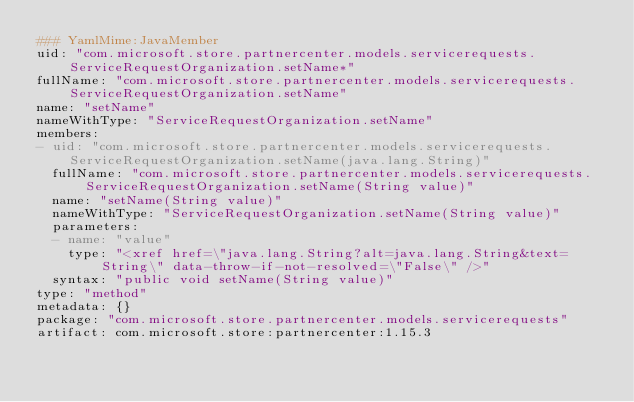<code> <loc_0><loc_0><loc_500><loc_500><_YAML_>### YamlMime:JavaMember
uid: "com.microsoft.store.partnercenter.models.servicerequests.ServiceRequestOrganization.setName*"
fullName: "com.microsoft.store.partnercenter.models.servicerequests.ServiceRequestOrganization.setName"
name: "setName"
nameWithType: "ServiceRequestOrganization.setName"
members:
- uid: "com.microsoft.store.partnercenter.models.servicerequests.ServiceRequestOrganization.setName(java.lang.String)"
  fullName: "com.microsoft.store.partnercenter.models.servicerequests.ServiceRequestOrganization.setName(String value)"
  name: "setName(String value)"
  nameWithType: "ServiceRequestOrganization.setName(String value)"
  parameters:
  - name: "value"
    type: "<xref href=\"java.lang.String?alt=java.lang.String&text=String\" data-throw-if-not-resolved=\"False\" />"
  syntax: "public void setName(String value)"
type: "method"
metadata: {}
package: "com.microsoft.store.partnercenter.models.servicerequests"
artifact: com.microsoft.store:partnercenter:1.15.3
</code> 